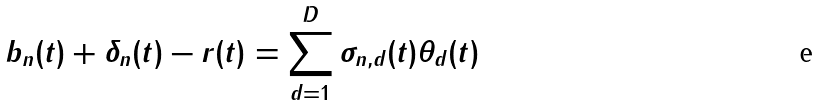Convert formula to latex. <formula><loc_0><loc_0><loc_500><loc_500>b _ { n } ( t ) + \delta _ { n } ( t ) - r ( t ) = \sum _ { d = 1 } ^ { D } \sigma _ { n , d } ( t ) \theta _ { d } ( t )</formula> 